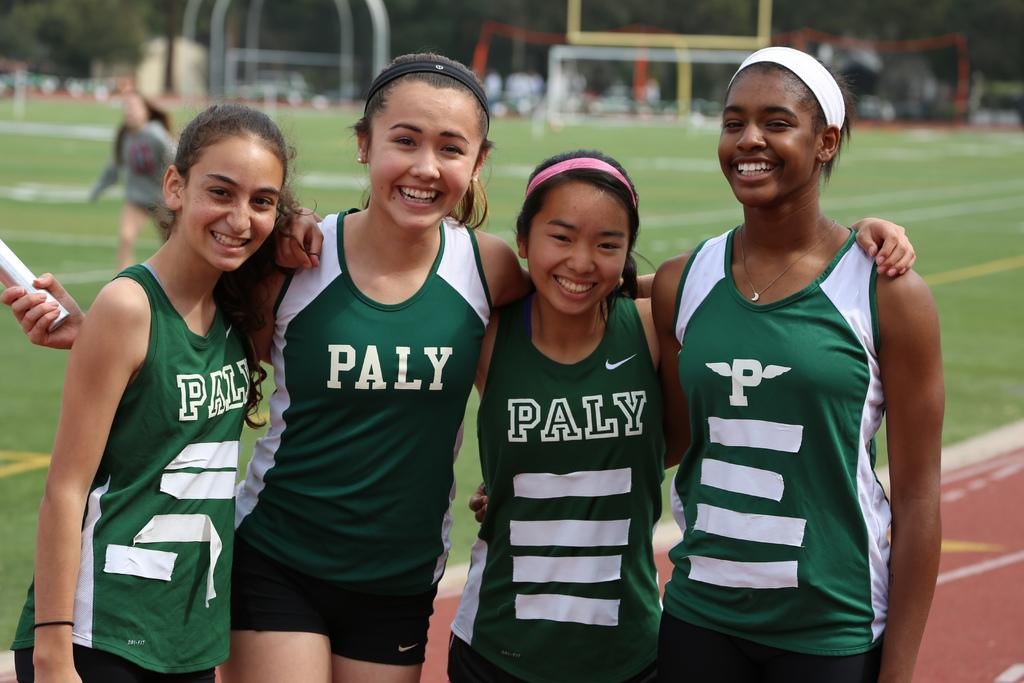<image>
Relay a brief, clear account of the picture shown. Four girls wearing Paly uniforms are posing on a racetrack. 